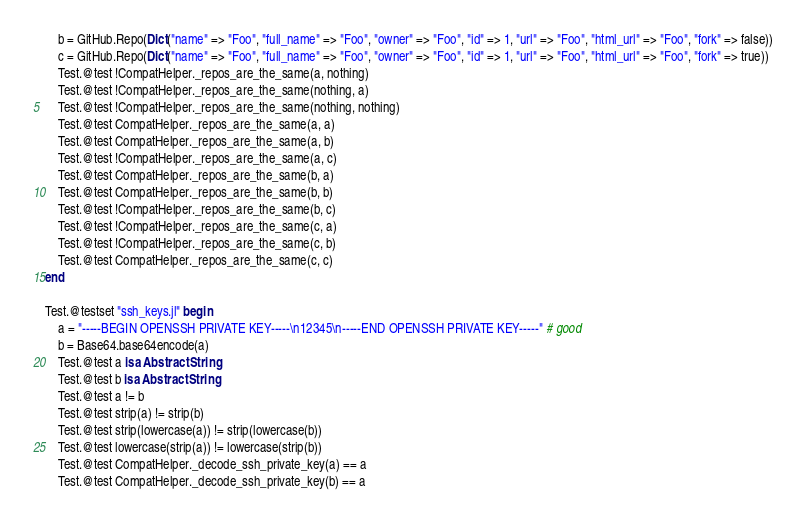Convert code to text. <code><loc_0><loc_0><loc_500><loc_500><_Julia_>    b = GitHub.Repo(Dict("name" => "Foo", "full_name" => "Foo", "owner" => "Foo", "id" => 1, "url" => "Foo", "html_url" => "Foo", "fork" => false))
    c = GitHub.Repo(Dict("name" => "Foo", "full_name" => "Foo", "owner" => "Foo", "id" => 1, "url" => "Foo", "html_url" => "Foo", "fork" => true))
    Test.@test !CompatHelper._repos_are_the_same(a, nothing)
    Test.@test !CompatHelper._repos_are_the_same(nothing, a)
    Test.@test !CompatHelper._repos_are_the_same(nothing, nothing)
    Test.@test CompatHelper._repos_are_the_same(a, a)
    Test.@test CompatHelper._repos_are_the_same(a, b)
    Test.@test !CompatHelper._repos_are_the_same(a, c)
    Test.@test CompatHelper._repos_are_the_same(b, a)
    Test.@test CompatHelper._repos_are_the_same(b, b)
    Test.@test !CompatHelper._repos_are_the_same(b, c)
    Test.@test !CompatHelper._repos_are_the_same(c, a)
    Test.@test !CompatHelper._repos_are_the_same(c, b)
    Test.@test CompatHelper._repos_are_the_same(c, c)
end

Test.@testset "ssh_keys.jl" begin
    a = "-----BEGIN OPENSSH PRIVATE KEY-----\n12345\n-----END OPENSSH PRIVATE KEY-----" # good
    b = Base64.base64encode(a)
    Test.@test a isa AbstractString
    Test.@test b isa AbstractString
    Test.@test a != b
    Test.@test strip(a) != strip(b)
    Test.@test strip(lowercase(a)) != strip(lowercase(b))
    Test.@test lowercase(strip(a)) != lowercase(strip(b))
    Test.@test CompatHelper._decode_ssh_private_key(a) == a
    Test.@test CompatHelper._decode_ssh_private_key(b) == a
</code> 